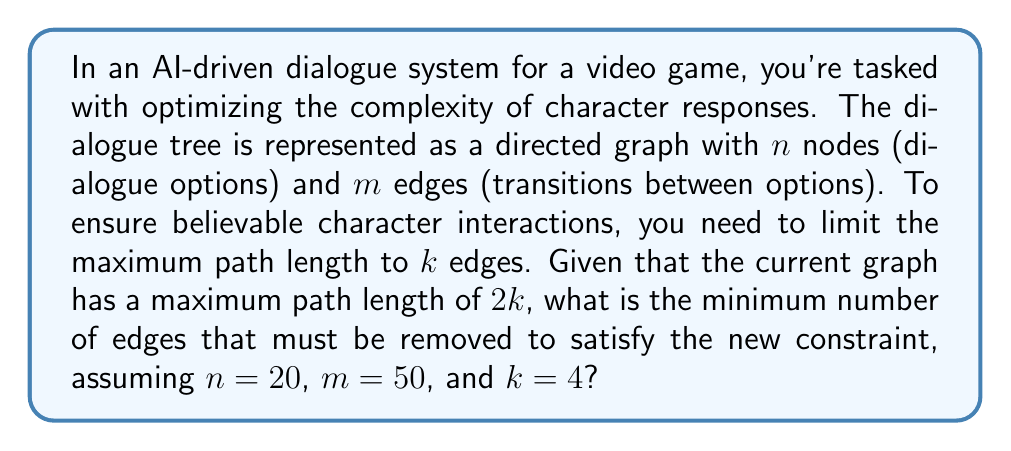Can you solve this math problem? To solve this problem, we'll use concepts from graph theory and decision trees:

1. First, we need to understand that the current maximum path length is $2k = 2 * 4 = 8$ edges.

2. We need to reduce this to $k = 4$ edges.

3. In a directed graph with $n$ nodes, the maximum number of edges in a path of length $k$ is given by:

   $$\text{Max edges} = \min(n(n-1)/2, n(k+1) - k(k+1)/2)$$

4. Substituting our values:
   $$\text{Max edges} = \min(20 * 19 / 2, 20 * 5 - 4 * 5 / 2)$$
   $$\text{Max edges} = \min(190, 90)$$
   $$\text{Max edges} = 90$$

5. This means that we can have at most 90 edges in our optimized graph to ensure no path is longer than 4 edges.

6. Currently, we have $m = 50$ edges, which is already less than 90.

7. Therefore, we don't need to remove any edges to satisfy the new constraint.
Answer: 0 edges 